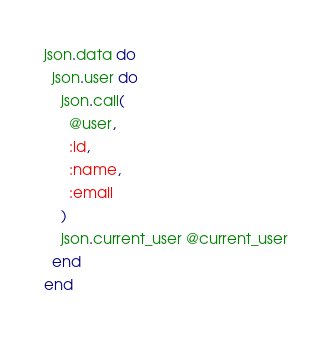<code> <loc_0><loc_0><loc_500><loc_500><_Ruby_>json.data do
  json.user do
    json.call(
      @user,
      :id,
      :name,
      :email
    )
    json.current_user @current_user
  end
end
</code> 